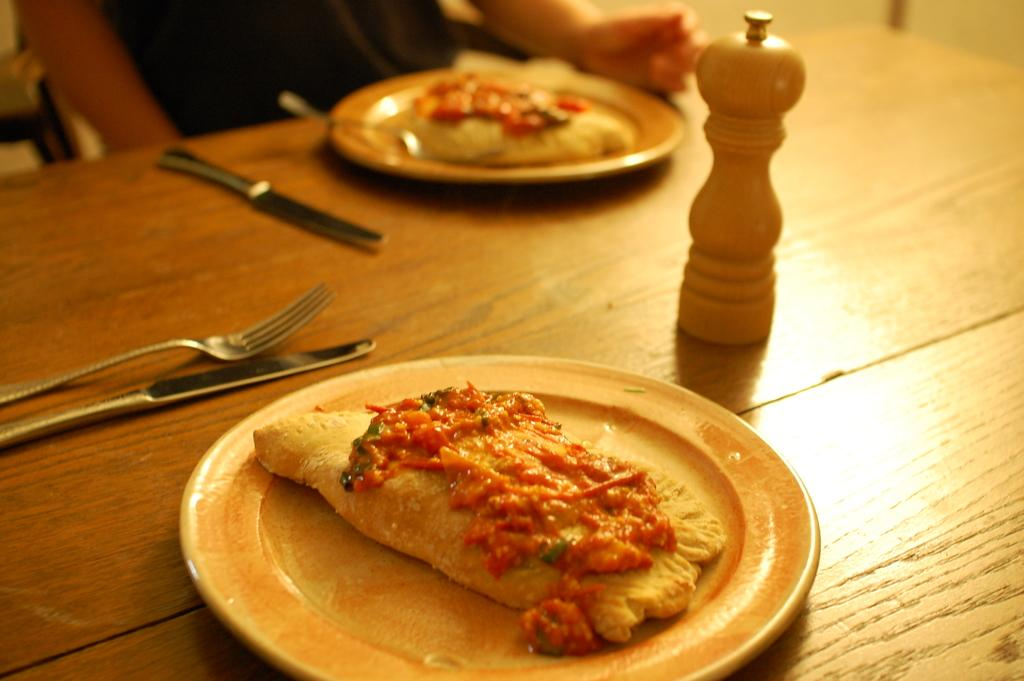What is the person in the image doing? The person is sitting on a chair in the image. What can be seen on the table in the image? There are objects placed on a table in the image. Can you see a stream flowing near the person in the image? There is no stream visible in the image. 